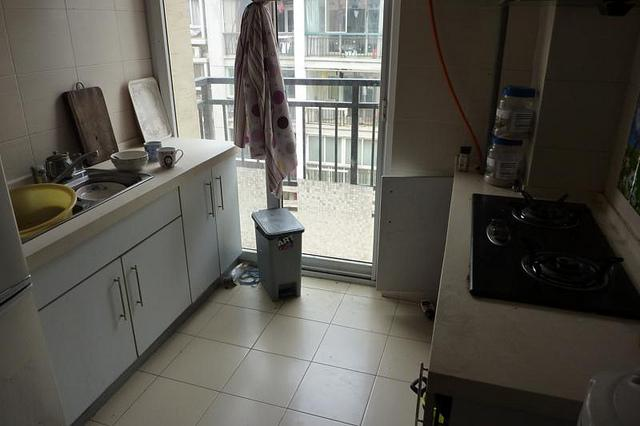In what type of housing complex is this kitchen part of? apartment 